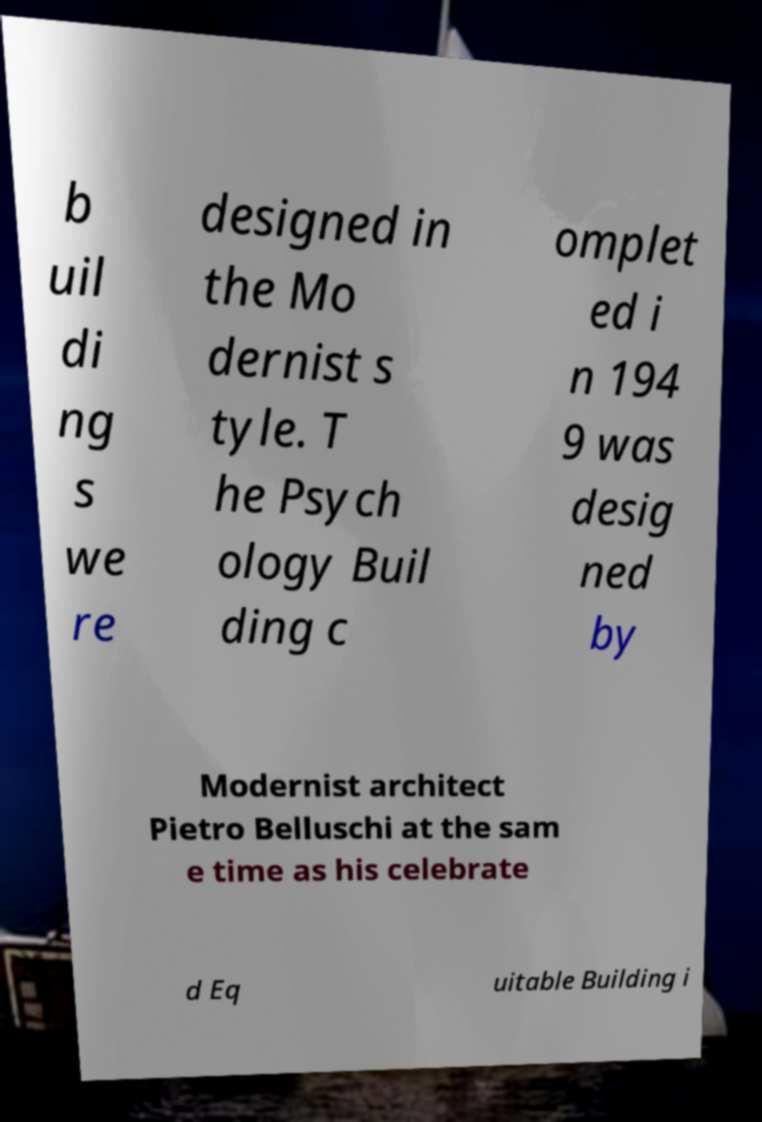Could you assist in decoding the text presented in this image and type it out clearly? b uil di ng s we re designed in the Mo dernist s tyle. T he Psych ology Buil ding c omplet ed i n 194 9 was desig ned by Modernist architect Pietro Belluschi at the sam e time as his celebrate d Eq uitable Building i 